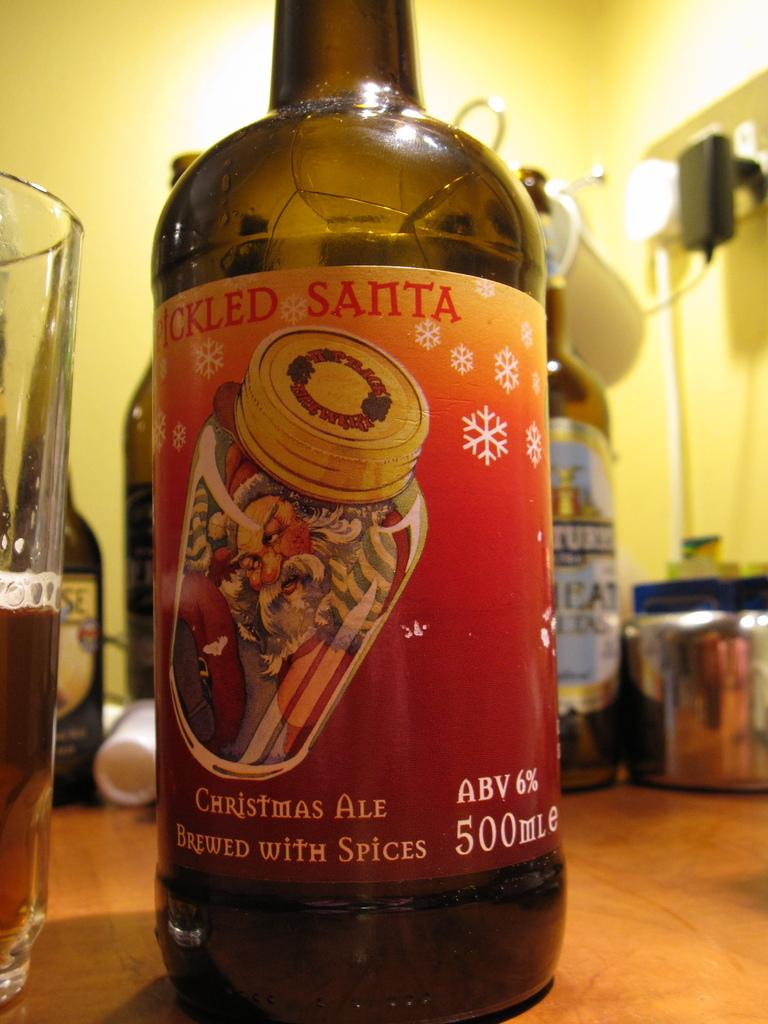<image>
Offer a succinct explanation of the picture presented. A bottle of a christmas ale brewed with spices 